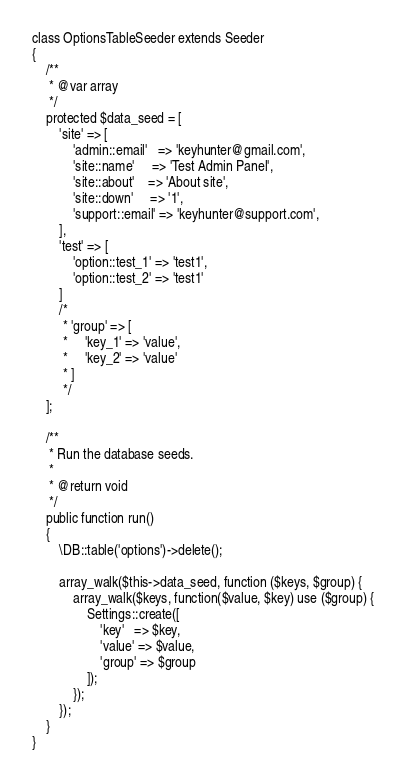Convert code to text. <code><loc_0><loc_0><loc_500><loc_500><_PHP_>
class OptionsTableSeeder extends Seeder
{
    /**
     * @var array
     */
    protected $data_seed = [
        'site' => [
            'admin::email'   => 'keyhunter@gmail.com',
            'site::name'     => 'Test Admin Panel',
            'site::about'    => 'About site',
            'site::down'     => '1',
            'support::email' => 'keyhunter@support.com',
        ],
        'test' => [
            'option::test_1' => 'test1',
            'option::test_2' => 'test1'
        ]
        /*
         * 'group' => [
         *     'key_1' => 'value',
         *     'key_2' => 'value'
         * ]
         */
    ];

    /**
     * Run the database seeds.
     *
     * @return void
     */
    public function run()
    {
        \DB::table('options')->delete();

        array_walk($this->data_seed, function ($keys, $group) {
            array_walk($keys, function($value, $key) use ($group) {
                Settings::create([
                    'key'   => $key,
                    'value' => $value,
                    'group' => $group
                ]);
            });
        });
    }
}</code> 